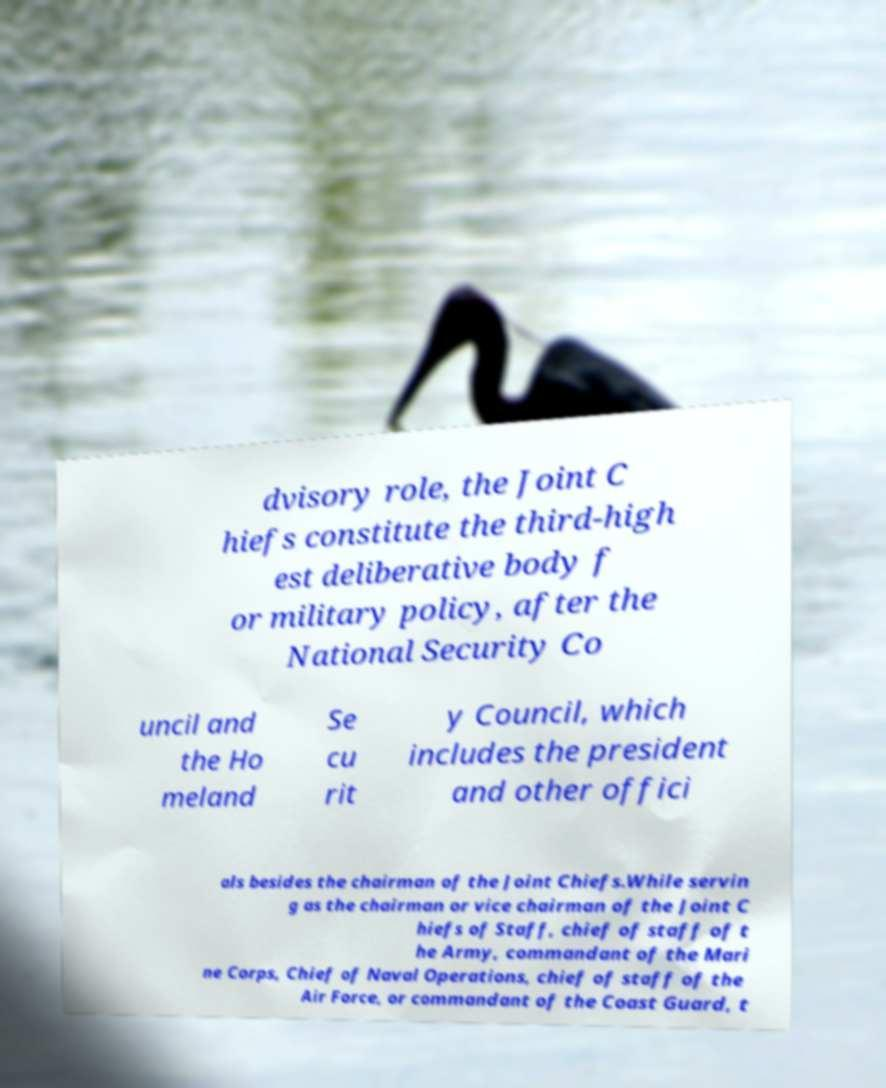Can you accurately transcribe the text from the provided image for me? dvisory role, the Joint C hiefs constitute the third-high est deliberative body f or military policy, after the National Security Co uncil and the Ho meland Se cu rit y Council, which includes the president and other offici als besides the chairman of the Joint Chiefs.While servin g as the chairman or vice chairman of the Joint C hiefs of Staff, chief of staff of t he Army, commandant of the Mari ne Corps, Chief of Naval Operations, chief of staff of the Air Force, or commandant of the Coast Guard, t 